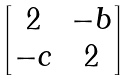<formula> <loc_0><loc_0><loc_500><loc_500>\begin{bmatrix} 2 & - b \\ - c & 2 \end{bmatrix}</formula> 